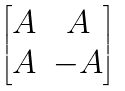<formula> <loc_0><loc_0><loc_500><loc_500>\begin{bmatrix} A & A \\ A & - A \end{bmatrix}</formula> 